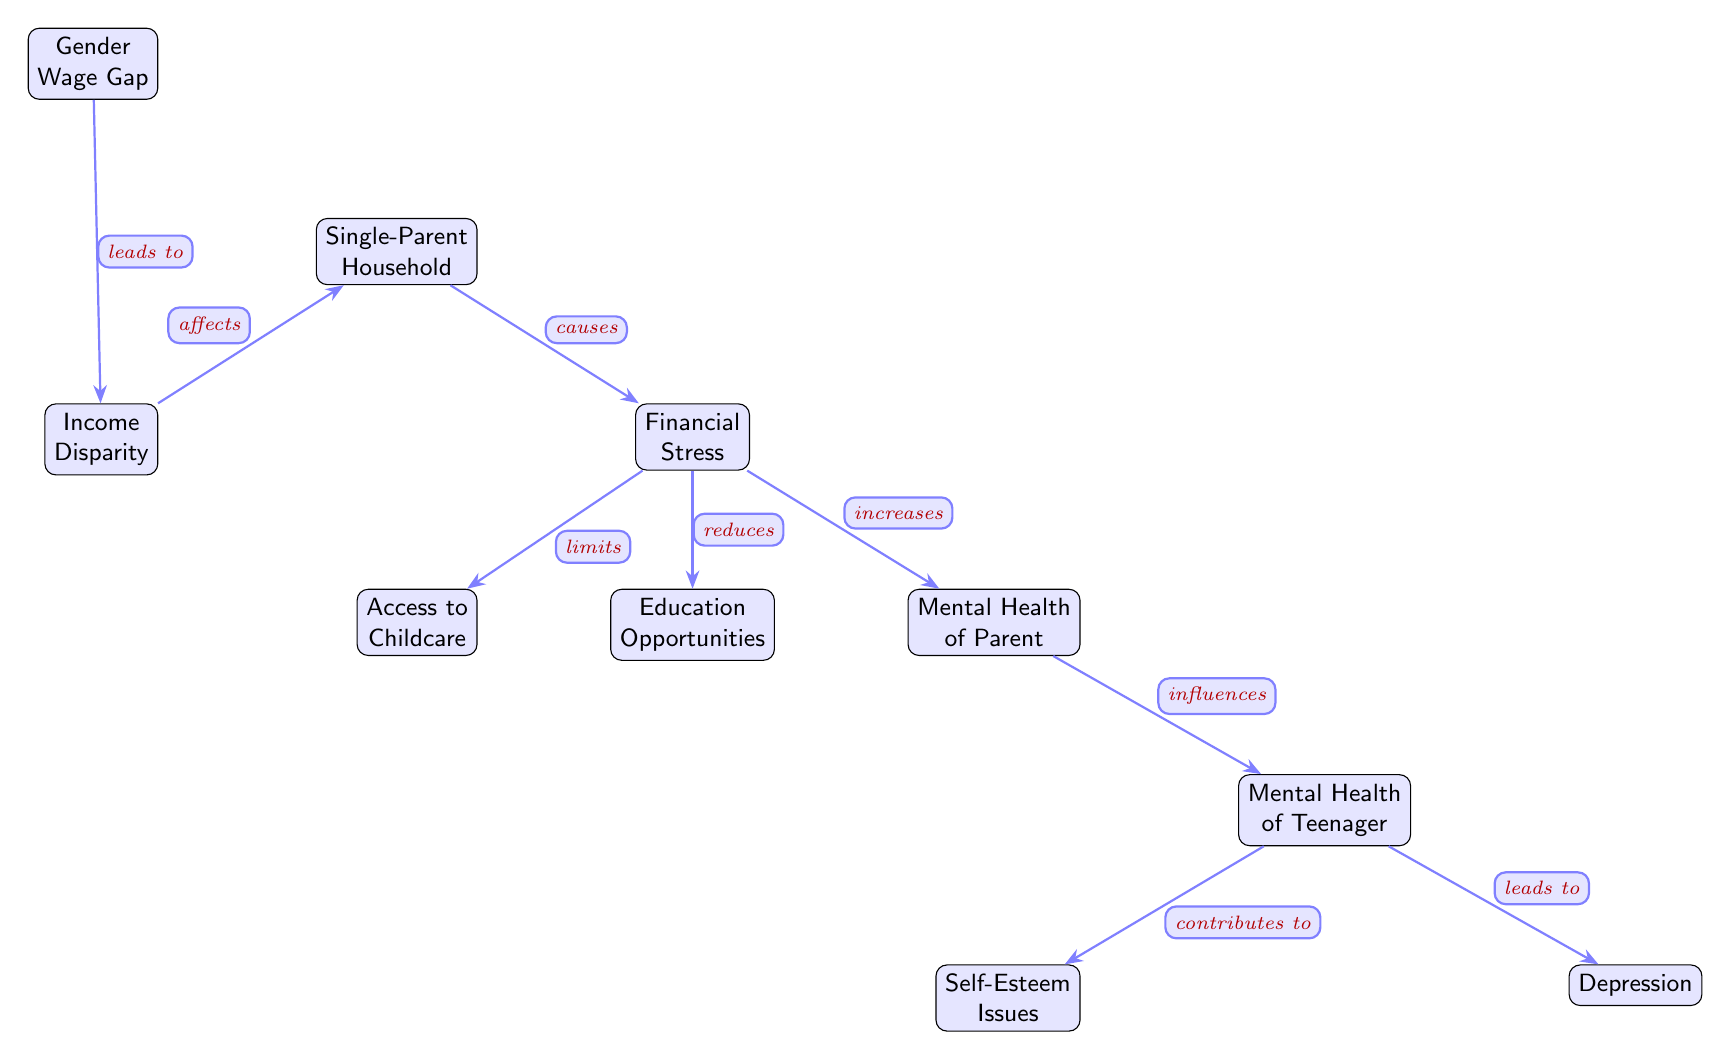What's the total number of nodes in the diagram? The diagram contains a total of ten nodes representing different concepts, which are interconnected through arrows indicating relationships.
Answer: 10 What is the relationship between the Gender Wage Gap and Income Disparity? The diagram shows that the Gender Wage Gap directly leads to Income Disparity, indicating that a wage gap results in varied income levels for individuals, especially in single-parent households.
Answer: leads to What is one effect of Financial Stress on Access to Childcare? The diagram illustrates that Financial Stress limits Access to Childcare, suggesting that when financial resources are strained, the ability to afford or utilize childcare services decreases.
Answer: limits Which node is influenced by Mental Health of Parent? The Mental Health of Parent influences the Mental Health of Teenager, showing a direct correlation between a parent's mental state and their child's mental well-being.
Answer: Mental Health of Teenager What does Single-Parent Household cause? The diagram indicates that a Single-Parent Household causes Financial Stress, which is a primary consequence of challenges related to managing household responsibilities alone.
Answer: causes How many relationships are there between Financial Stress and other nodes? The Financial Stress node has three relationships indicated: it limits Access to Childcare, reduces Education Opportunities, and increases Mental Health of Parent.
Answer: 3 What is the final outcome that Mental Health of Teenager leads to? According to the diagram, the final outcome that the Mental Health of Teenager leads to is Depression, demonstrating a potential consequence of poor mental health during adolescence.
Answer: Depression Which factor contributes to Self-Esteem Issues? The diagram illustrates that Self-Esteem Issues are a contributing factor stemming from the Mental Health of Teenager, indicating that mental health challenges during teenage years can lead to self-esteem difficulties.
Answer: Mental Health of Teenager What does Income Disparity affect directly? Income Disparity directly affects the Single-Parent Household, suggesting that disparities in income can impact the living conditions and experiences of single-parent families.
Answer: affects 